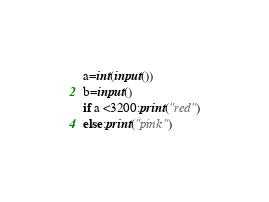<code> <loc_0><loc_0><loc_500><loc_500><_Python_>a=int(input())
b=input()
if a <3200:print("red")
else:print("pink")</code> 